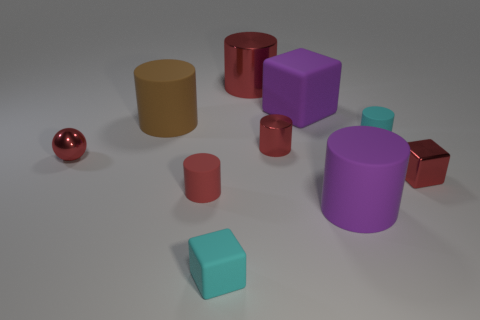Subtract all red cylinders. How many were subtracted if there are1red cylinders left? 2 Subtract all red spheres. How many red cylinders are left? 3 Subtract all brown cylinders. How many cylinders are left? 5 Subtract all tiny red shiny cylinders. How many cylinders are left? 5 Subtract all gray cylinders. Subtract all cyan blocks. How many cylinders are left? 6 Subtract all cylinders. How many objects are left? 4 Subtract all small cylinders. Subtract all red rubber cylinders. How many objects are left? 6 Add 5 large cubes. How many large cubes are left? 6 Add 1 big rubber cylinders. How many big rubber cylinders exist? 3 Subtract 1 purple blocks. How many objects are left? 9 